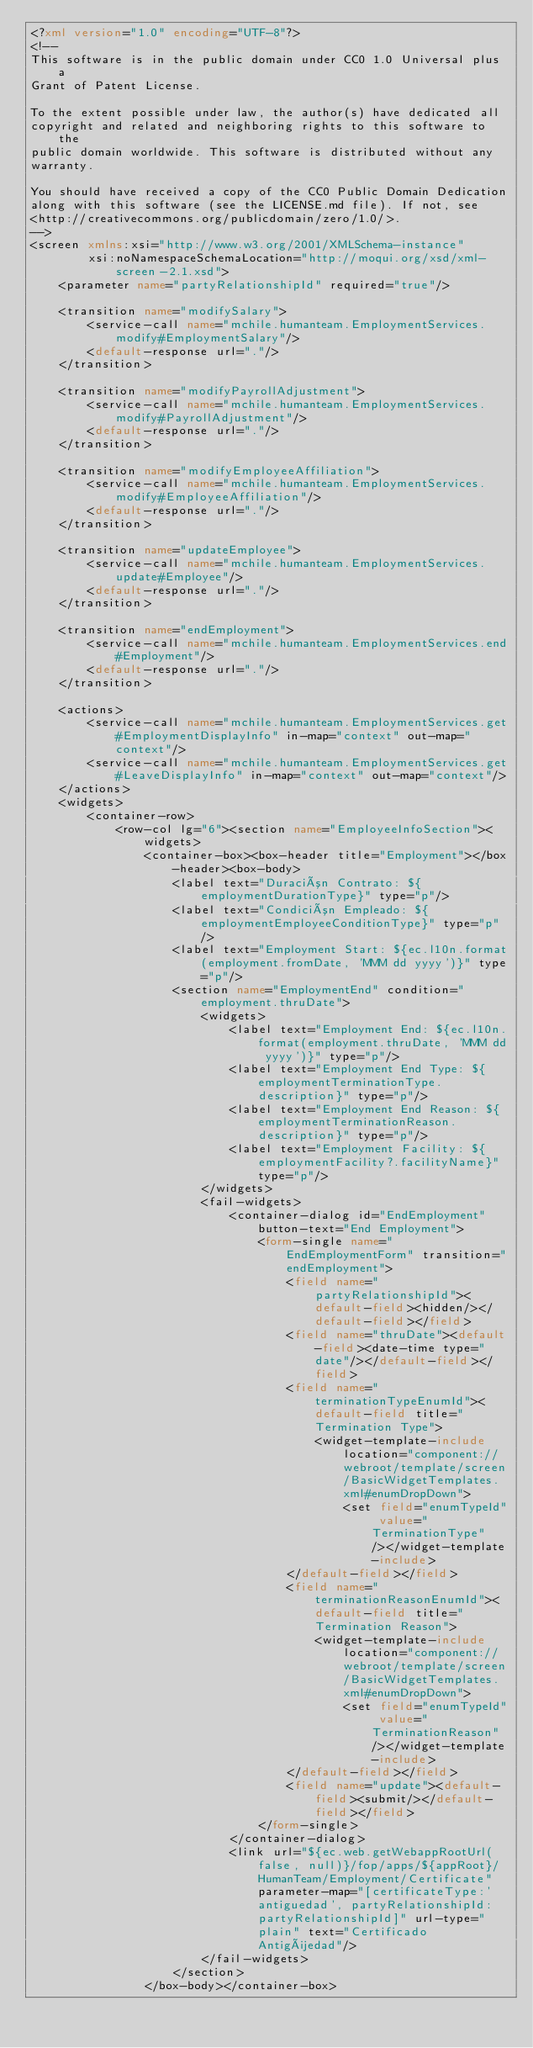<code> <loc_0><loc_0><loc_500><loc_500><_XML_><?xml version="1.0" encoding="UTF-8"?>
<!--
This software is in the public domain under CC0 1.0 Universal plus a
Grant of Patent License.

To the extent possible under law, the author(s) have dedicated all
copyright and related and neighboring rights to this software to the
public domain worldwide. This software is distributed without any
warranty.

You should have received a copy of the CC0 Public Domain Dedication
along with this software (see the LICENSE.md file). If not, see
<http://creativecommons.org/publicdomain/zero/1.0/>.
-->
<screen xmlns:xsi="http://www.w3.org/2001/XMLSchema-instance"
        xsi:noNamespaceSchemaLocation="http://moqui.org/xsd/xml-screen-2.1.xsd">
    <parameter name="partyRelationshipId" required="true"/>

    <transition name="modifySalary">
        <service-call name="mchile.humanteam.EmploymentServices.modify#EmploymentSalary"/>
        <default-response url="."/>
    </transition>

    <transition name="modifyPayrollAdjustment">
        <service-call name="mchile.humanteam.EmploymentServices.modify#PayrollAdjustment"/>
        <default-response url="."/>
    </transition>

    <transition name="modifyEmployeeAffiliation">
        <service-call name="mchile.humanteam.EmploymentServices.modify#EmployeeAffiliation"/>
        <default-response url="."/>
    </transition>

    <transition name="updateEmployee">
        <service-call name="mchile.humanteam.EmploymentServices.update#Employee"/>
        <default-response url="."/>
    </transition>

    <transition name="endEmployment">
        <service-call name="mchile.humanteam.EmploymentServices.end#Employment"/>
        <default-response url="."/>
    </transition>

    <actions>
        <service-call name="mchile.humanteam.EmploymentServices.get#EmploymentDisplayInfo" in-map="context" out-map="context"/>
        <service-call name="mchile.humanteam.EmploymentServices.get#LeaveDisplayInfo" in-map="context" out-map="context"/>
    </actions>
    <widgets>
        <container-row>
            <row-col lg="6"><section name="EmployeeInfoSection"><widgets>
                <container-box><box-header title="Employment"></box-header><box-body>
                    <label text="Duración Contrato: ${employmentDurationType}" type="p"/>
                    <label text="Condición Empleado: ${employmentEmployeeConditionType}" type="p"/>
                    <label text="Employment Start: ${ec.l10n.format(employment.fromDate, 'MMM dd yyyy')}" type="p"/>
                    <section name="EmploymentEnd" condition="employment.thruDate">
                        <widgets>
                            <label text="Employment End: ${ec.l10n.format(employment.thruDate, 'MMM dd yyyy')}" type="p"/>
                            <label text="Employment End Type: ${employmentTerminationType.description}" type="p"/>
                            <label text="Employment End Reason: ${employmentTerminationReason.description}" type="p"/>
                            <label text="Employment Facility: ${employmentFacility?.facilityName}" type="p"/>
                        </widgets>
                        <fail-widgets>
                            <container-dialog id="EndEmployment" button-text="End Employment">
                                <form-single name="EndEmploymentForm" transition="endEmployment">
                                    <field name="partyRelationshipId"><default-field><hidden/></default-field></field>
                                    <field name="thruDate"><default-field><date-time type="date"/></default-field></field>
                                    <field name="terminationTypeEnumId"><default-field title="Termination Type">
                                        <widget-template-include location="component://webroot/template/screen/BasicWidgetTemplates.xml#enumDropDown">
                                            <set field="enumTypeId" value="TerminationType"/></widget-template-include>
                                    </default-field></field>
                                    <field name="terminationReasonEnumId"><default-field title="Termination Reason">
                                        <widget-template-include location="component://webroot/template/screen/BasicWidgetTemplates.xml#enumDropDown">
                                            <set field="enumTypeId" value="TerminationReason"/></widget-template-include>
                                    </default-field></field>
                                    <field name="update"><default-field><submit/></default-field></field>
                                </form-single>
                            </container-dialog>
                            <link url="${ec.web.getWebappRootUrl(false, null)}/fop/apps/${appRoot}/HumanTeam/Employment/Certificate" parameter-map="[certificateType:'antiguedad', partyRelationshipId:partyRelationshipId]" url-type="plain" text="Certificado Antigüedad"/>
                        </fail-widgets>
                    </section>
                </box-body></container-box></code> 